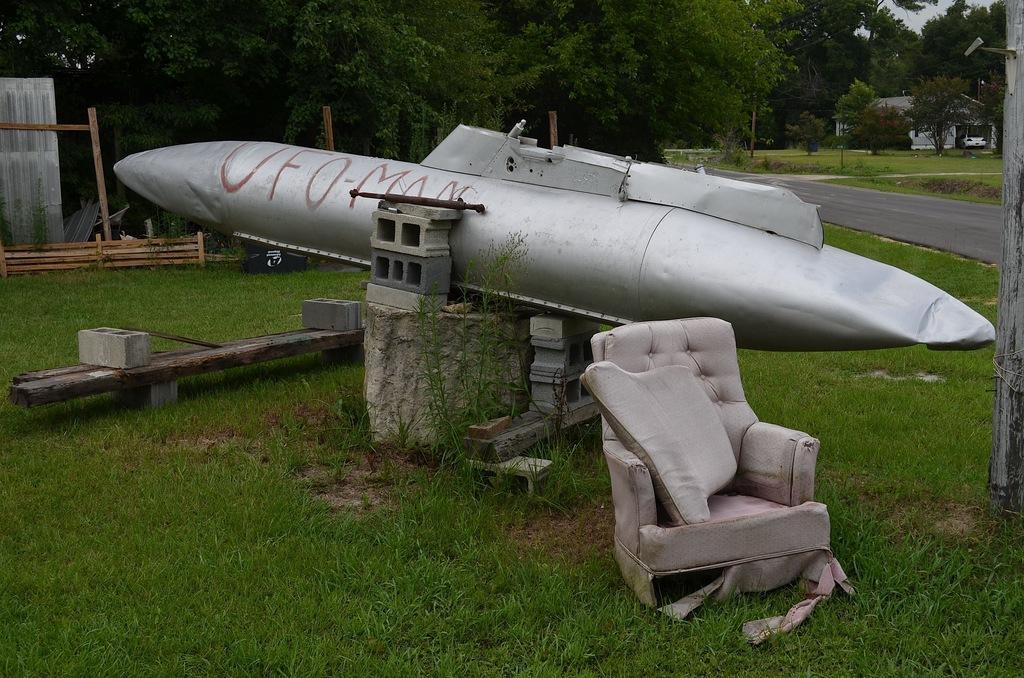In one or two sentences, can you explain what this image depicts? In this image there is a broken chair. And this few other things. It is looking like a part of a rocket. In the background there are trees , building and a road is passing by. 